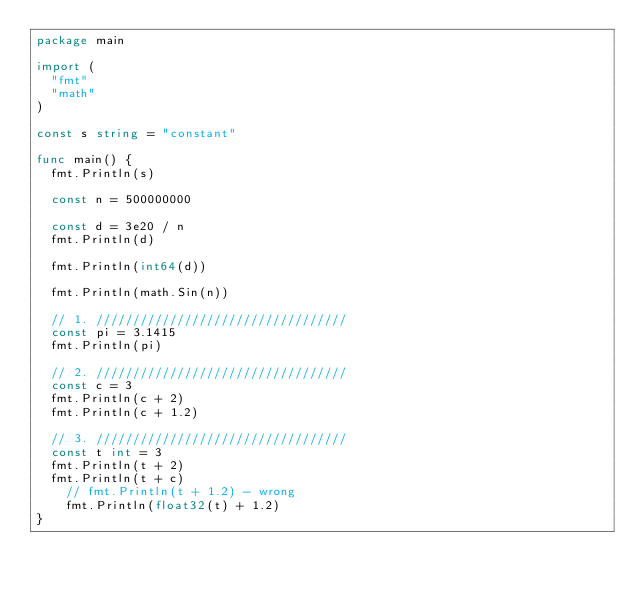<code> <loc_0><loc_0><loc_500><loc_500><_Go_>package main

import (
	"fmt"
	"math"
)

const s string = "constant"

func main() {
	fmt.Println(s)

	const n = 500000000

	const d = 3e20 / n
	fmt.Println(d)

	fmt.Println(int64(d))

	fmt.Println(math.Sin(n))

	// 1. //////////////////////////////////
	const pi = 3.1415
	fmt.Println(pi)

	// 2. //////////////////////////////////
	const c = 3
	fmt.Println(c + 2)
	fmt.Println(c + 1.2)

	// 3. //////////////////////////////////
	const t int = 3
	fmt.Println(t + 2)
	fmt.Println(t + c)
    // fmt.Println(t + 1.2) - wrong
    fmt.Println(float32(t) + 1.2)
}
</code> 